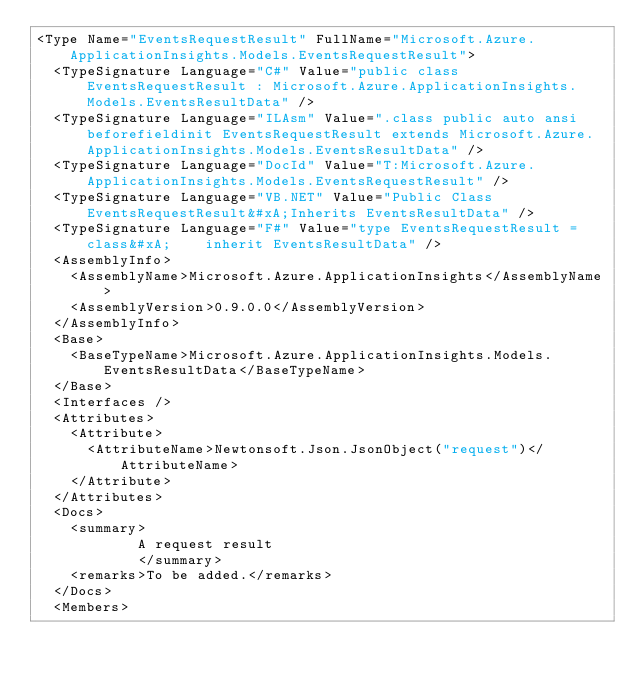Convert code to text. <code><loc_0><loc_0><loc_500><loc_500><_XML_><Type Name="EventsRequestResult" FullName="Microsoft.Azure.ApplicationInsights.Models.EventsRequestResult">
  <TypeSignature Language="C#" Value="public class EventsRequestResult : Microsoft.Azure.ApplicationInsights.Models.EventsResultData" />
  <TypeSignature Language="ILAsm" Value=".class public auto ansi beforefieldinit EventsRequestResult extends Microsoft.Azure.ApplicationInsights.Models.EventsResultData" />
  <TypeSignature Language="DocId" Value="T:Microsoft.Azure.ApplicationInsights.Models.EventsRequestResult" />
  <TypeSignature Language="VB.NET" Value="Public Class EventsRequestResult&#xA;Inherits EventsResultData" />
  <TypeSignature Language="F#" Value="type EventsRequestResult = class&#xA;    inherit EventsResultData" />
  <AssemblyInfo>
    <AssemblyName>Microsoft.Azure.ApplicationInsights</AssemblyName>
    <AssemblyVersion>0.9.0.0</AssemblyVersion>
  </AssemblyInfo>
  <Base>
    <BaseTypeName>Microsoft.Azure.ApplicationInsights.Models.EventsResultData</BaseTypeName>
  </Base>
  <Interfaces />
  <Attributes>
    <Attribute>
      <AttributeName>Newtonsoft.Json.JsonObject("request")</AttributeName>
    </Attribute>
  </Attributes>
  <Docs>
    <summary>
            A request result
            </summary>
    <remarks>To be added.</remarks>
  </Docs>
  <Members></code> 